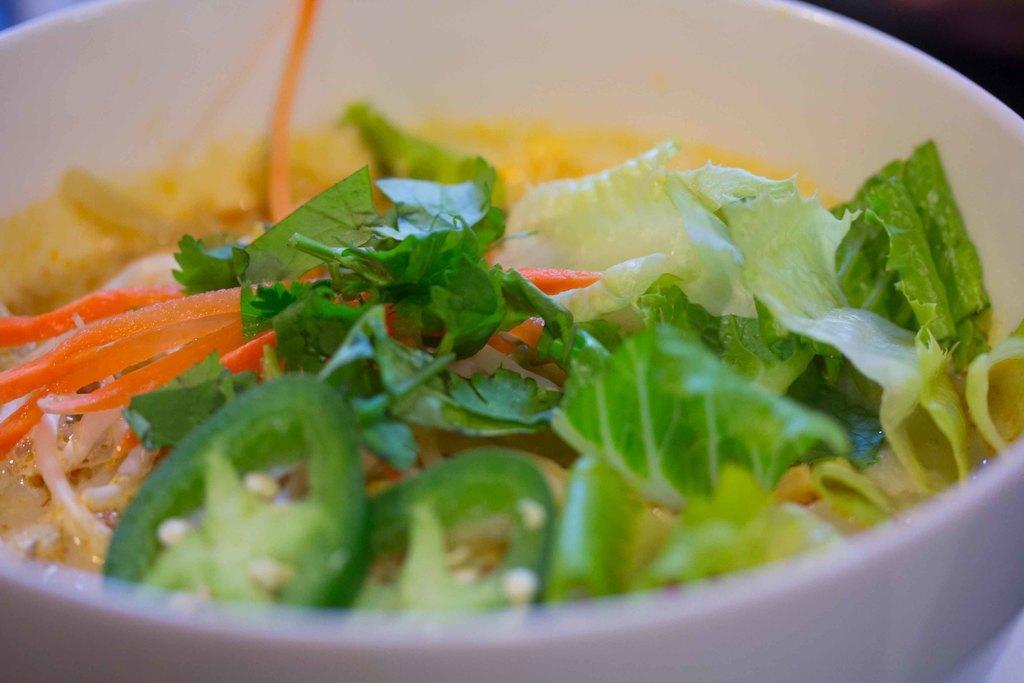Can you describe this image briefly? In this image there is a bowl. There is food in the bowl. In the food there are onions, carrots, jalapeno, parsley, cabbage and lettuce. 